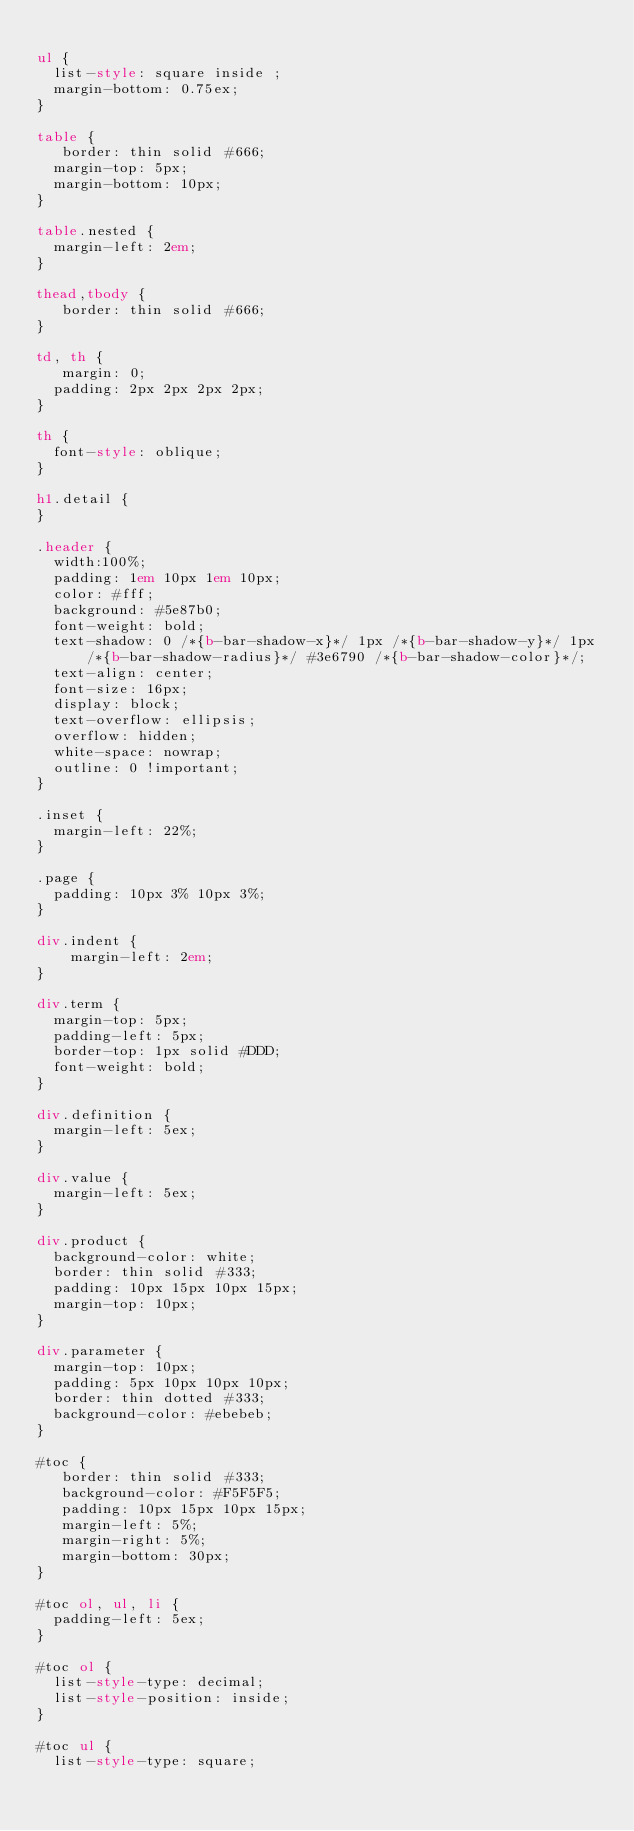Convert code to text. <code><loc_0><loc_0><loc_500><loc_500><_HTML_>
ul {
	list-style: square inside ;
	margin-bottom: 0.75ex;
}

table {
   border: thin solid #666;
	margin-top: 5px;
	margin-bottom: 10px;
}

table.nested {
	margin-left: 2em;
}

thead,tbody {
   border: thin solid #666;
}

td, th {
   margin: 0;
	padding: 2px 2px 2px 2px;
}

th {
	font-style: oblique;
}

h1.detail {
}

.header {
	width:100%;
	padding: 1em 10px 1em 10px;
	color: #fff;
	background: #5e87b0;
	font-weight: bold;
	text-shadow: 0 /*{b-bar-shadow-x}*/ 1px /*{b-bar-shadow-y}*/ 1px /*{b-bar-shadow-radius}*/ #3e6790 /*{b-bar-shadow-color}*/;
	text-align: center;
	font-size: 16px;
	display: block;
	text-overflow: ellipsis;
	overflow: hidden;
	white-space: nowrap;
	outline: 0 !important;
}

.inset {
	margin-left: 22%;
}

.page {
	padding: 10px 3% 10px 3%;
}

div.indent {
    margin-left: 2em;
}

div.term {
	margin-top: 5px;
	padding-left: 5px;
	border-top: 1px solid #DDD;
	font-weight: bold;
}

div.definition {
	margin-left: 5ex;
}

div.value {
	margin-left: 5ex;
}

div.product {
	background-color: white;
	border: thin solid #333;
	padding: 10px 15px 10px 15px;
	margin-top: 10px;
}

div.parameter {
	margin-top: 10px;
	padding: 5px 10px 10px 10px;
	border: thin dotted #333;
	background-color: #ebebeb;
}

#toc {
   border: thin solid #333;
   background-color: #F5F5F5; 
   padding: 10px 15px 10px 15px;
   margin-left: 5%;
   margin-right: 5%;
   margin-bottom: 30px;
}

#toc ol, ul, li {
	padding-left: 5ex;
}

#toc ol {
	list-style-type: decimal;
	list-style-position: inside; 
}

#toc ul {
	list-style-type: square;</code> 